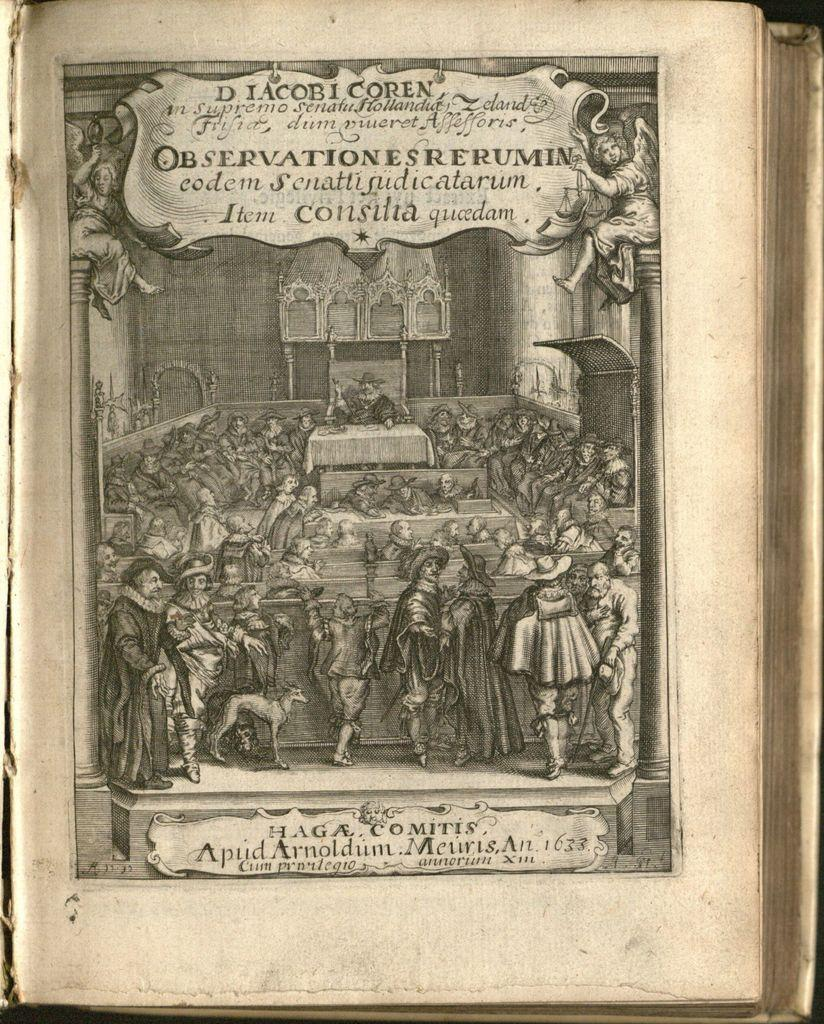Provide a one-sentence caption for the provided image. A black and white photo from an old book showing a courthouse scene  with "D IacobI Coren" at the top of the page. 